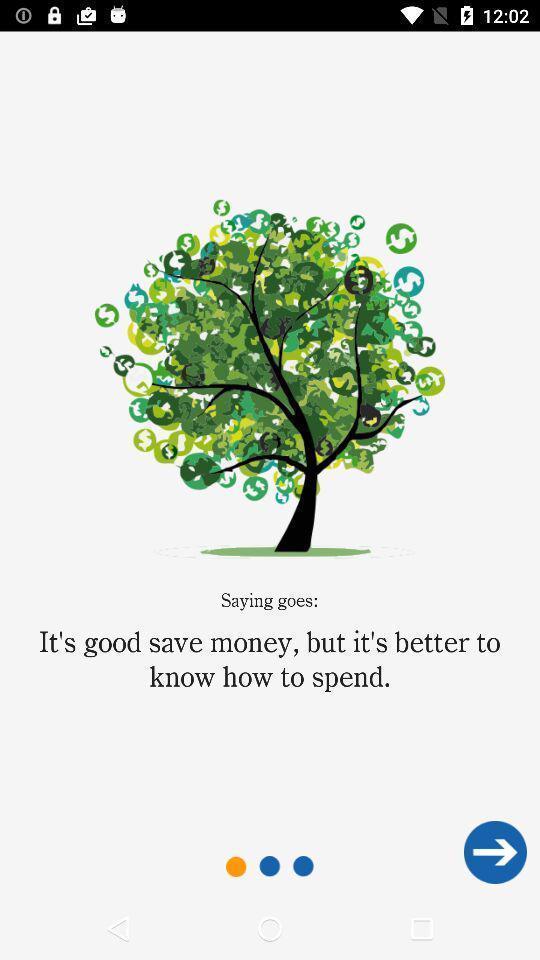What is the overall content of this screenshot? Welcome page for the budget planning app. 